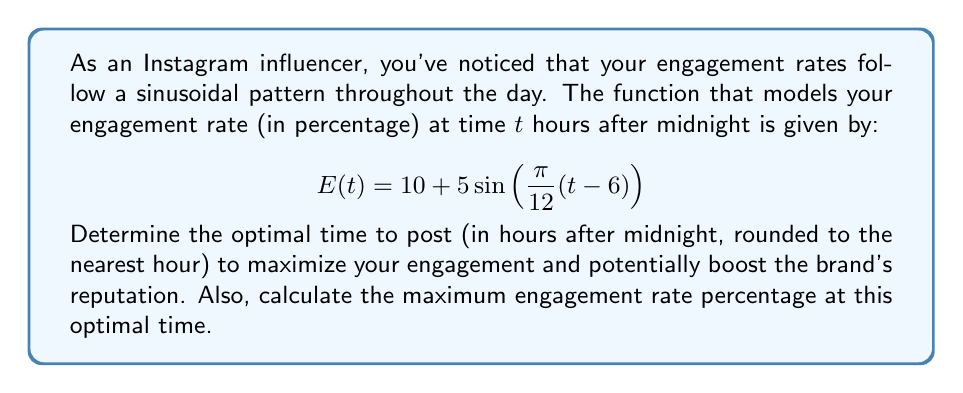Can you solve this math problem? To find the optimal posting time, we need to determine when the engagement rate function $E(t)$ reaches its maximum value. For a sinusoidal function of the form $a\sin(b(t-c)) + d$, the maximum occurs when $b(t-c) = \frac{\pi}{2}$ or $\frac{5\pi}{2}$.

1) In our case, $a=5$, $b=\frac{\pi}{12}$, $c=6$, and $d=10$.

2) Set up the equation:
   $$\frac{\pi}{12}(t-6) = \frac{\pi}{2}$$

3) Solve for $t$:
   $$t-6 = 6$$
   $$t = 12$$

4) This means the optimal posting time is 12 hours after midnight, or 12:00 PM (noon).

5) To calculate the maximum engagement rate, substitute $t=12$ into the original function:

   $$E(12) = 10 + 5\sin\left(\frac{\pi}{12}(12-6)\right)$$
   $$= 10 + 5\sin\left(\frac{\pi}{2}\right)$$
   $$= 10 + 5(1)$$
   $$= 15$$

Therefore, the maximum engagement rate is 15%.
Answer: The optimal posting time is 12 hours after midnight (12:00 PM), and the maximum engagement rate at this time is 15%. 